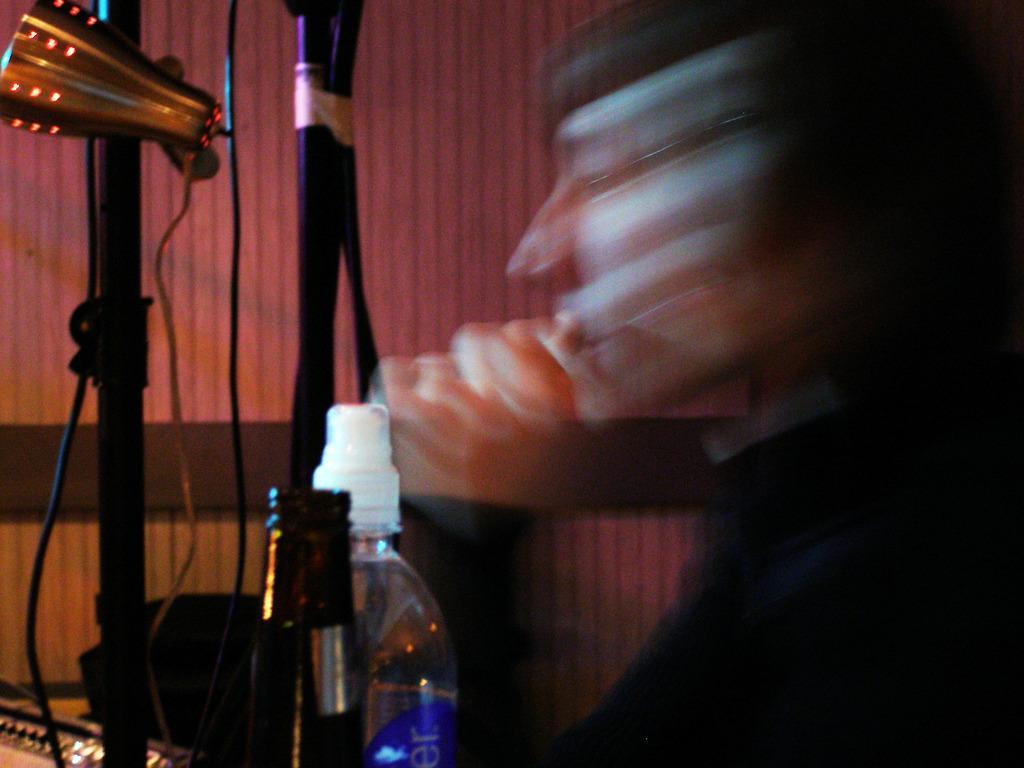Can you describe this image briefly? At the bottom of the image there are some bottles and poles and wires. Behind them there is wall, on the right side of the image is blur. 